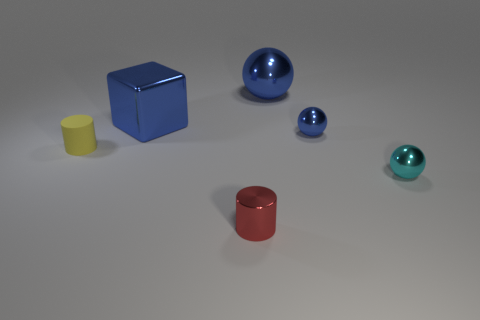Does the lighting suggest a particular time of day or setting? The lighting in the image seems artificial and diffused, consistent with an indoor setting where objects are illuminated evenly for clarity. There is no indication of a specific time of day, as the shadows are soft and do not reveal a direct light source such as the sun. 